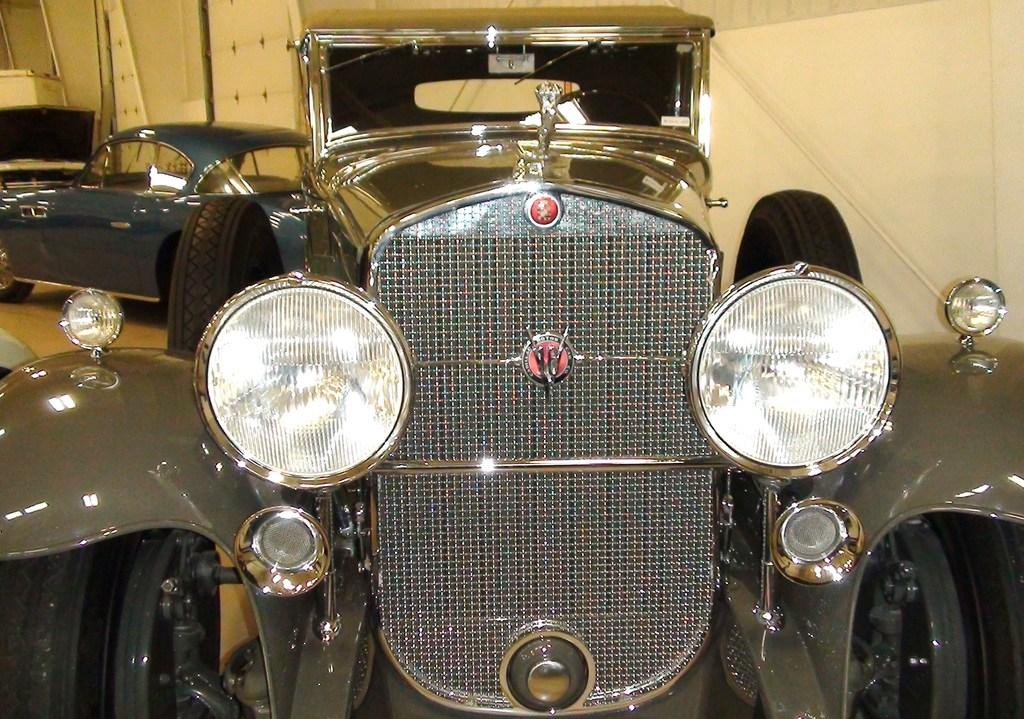How many vehicles are present in the image? There are two vehicles in the image. Where are the vehicles located? The vehicles are on the floor. What can be seen in the background of the image? There is a wall in the background of the image. What type of beef is being discussed at the meeting in the image? There is no meeting or beef present in the image; it features two vehicles on the floor with a wall in the background. Is the farmer present in the image? There is no farmer present in the image. 